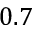<formula> <loc_0><loc_0><loc_500><loc_500>0 . 7</formula> 